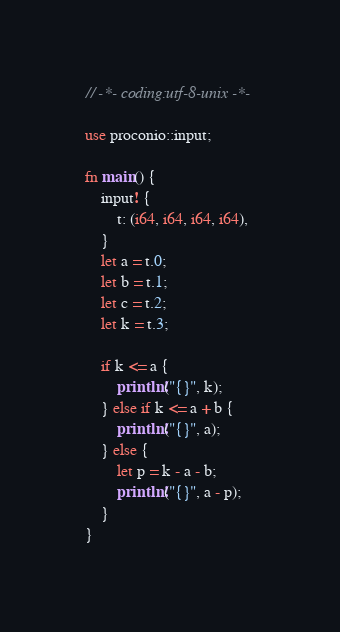Convert code to text. <code><loc_0><loc_0><loc_500><loc_500><_Rust_>// -*- coding:utf-8-unix -*-

use proconio::input;

fn main() {
    input! {
        t: (i64, i64, i64, i64),
    }
    let a = t.0;
    let b = t.1;
    let c = t.2;
    let k = t.3;

    if k <= a {
        println!("{}", k);
    } else if k <= a + b {
        println!("{}", a);
    } else {
        let p = k - a - b;
        println!("{}", a - p);
    }
}</code> 